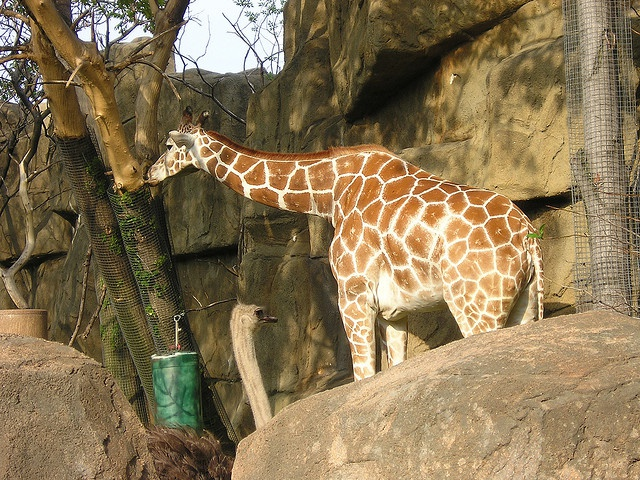Describe the objects in this image and their specific colors. I can see giraffe in white, tan, beige, and red tones and bird in ivory and tan tones in this image. 